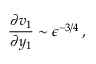<formula> <loc_0><loc_0><loc_500><loc_500>\frac { \partial v _ { 1 } } { \partial y _ { 1 } } \sim \epsilon ^ { - 3 / 4 } \, ,</formula> 